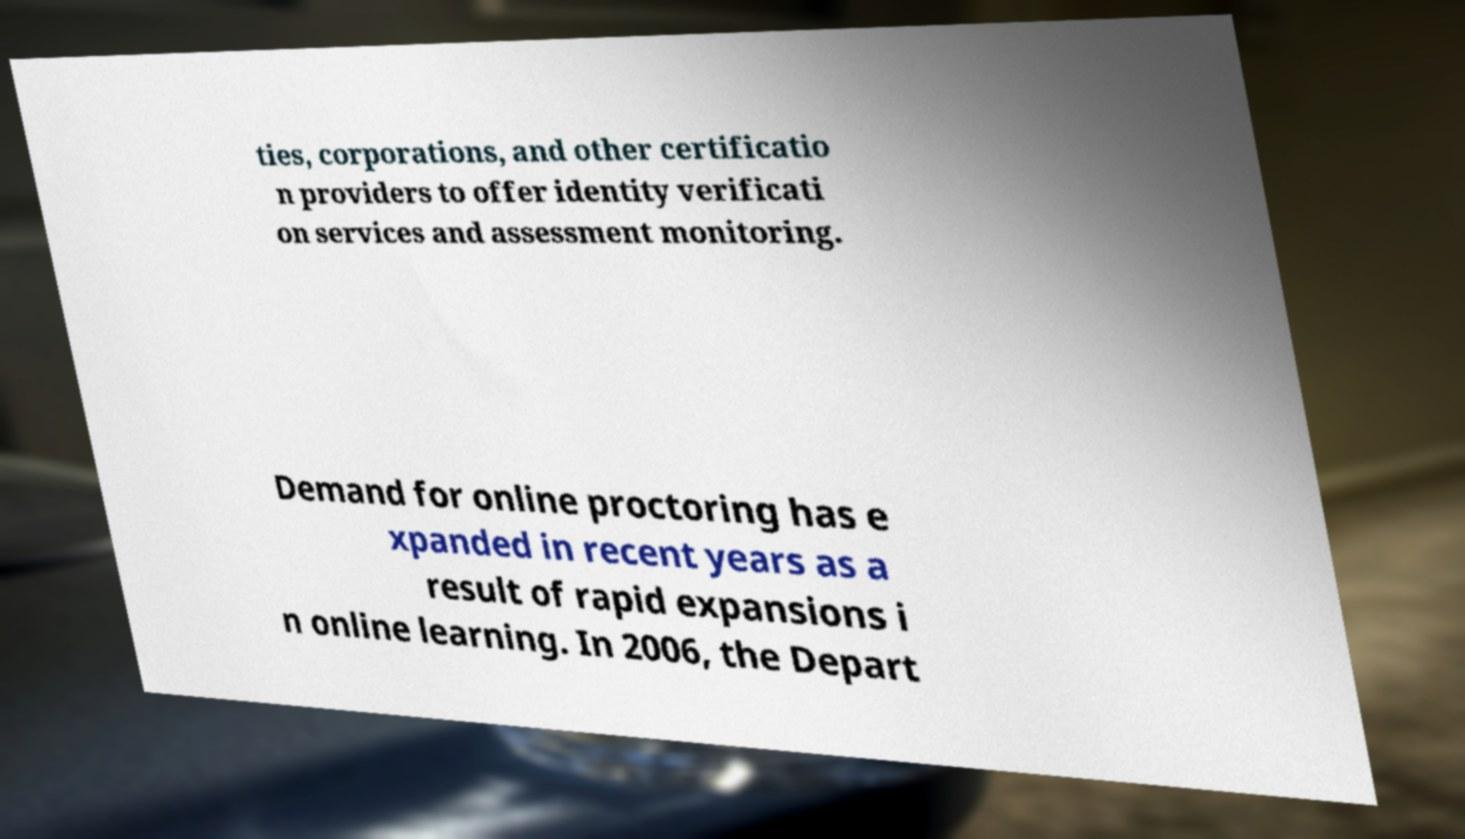There's text embedded in this image that I need extracted. Can you transcribe it verbatim? ties, corporations, and other certificatio n providers to offer identity verificati on services and assessment monitoring. Demand for online proctoring has e xpanded in recent years as a result of rapid expansions i n online learning. In 2006, the Depart 